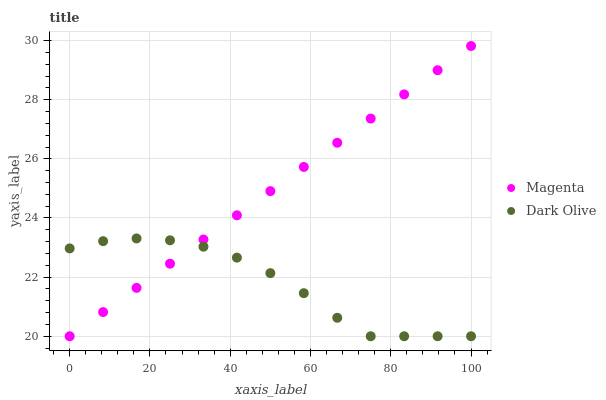Does Dark Olive have the minimum area under the curve?
Answer yes or no. Yes. Does Magenta have the maximum area under the curve?
Answer yes or no. Yes. Does Dark Olive have the maximum area under the curve?
Answer yes or no. No. Is Magenta the smoothest?
Answer yes or no. Yes. Is Dark Olive the roughest?
Answer yes or no. Yes. Is Dark Olive the smoothest?
Answer yes or no. No. Does Magenta have the lowest value?
Answer yes or no. Yes. Does Magenta have the highest value?
Answer yes or no. Yes. Does Dark Olive have the highest value?
Answer yes or no. No. Does Magenta intersect Dark Olive?
Answer yes or no. Yes. Is Magenta less than Dark Olive?
Answer yes or no. No. Is Magenta greater than Dark Olive?
Answer yes or no. No. 